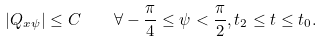Convert formula to latex. <formula><loc_0><loc_0><loc_500><loc_500>| Q _ { x \psi } | \leq C \quad \forall - \frac { \pi } { 4 } \leq \psi < \frac { \pi } { 2 } , t _ { 2 } \leq t \leq t _ { 0 } .</formula> 